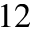Convert formula to latex. <formula><loc_0><loc_0><loc_500><loc_500>1 2</formula> 